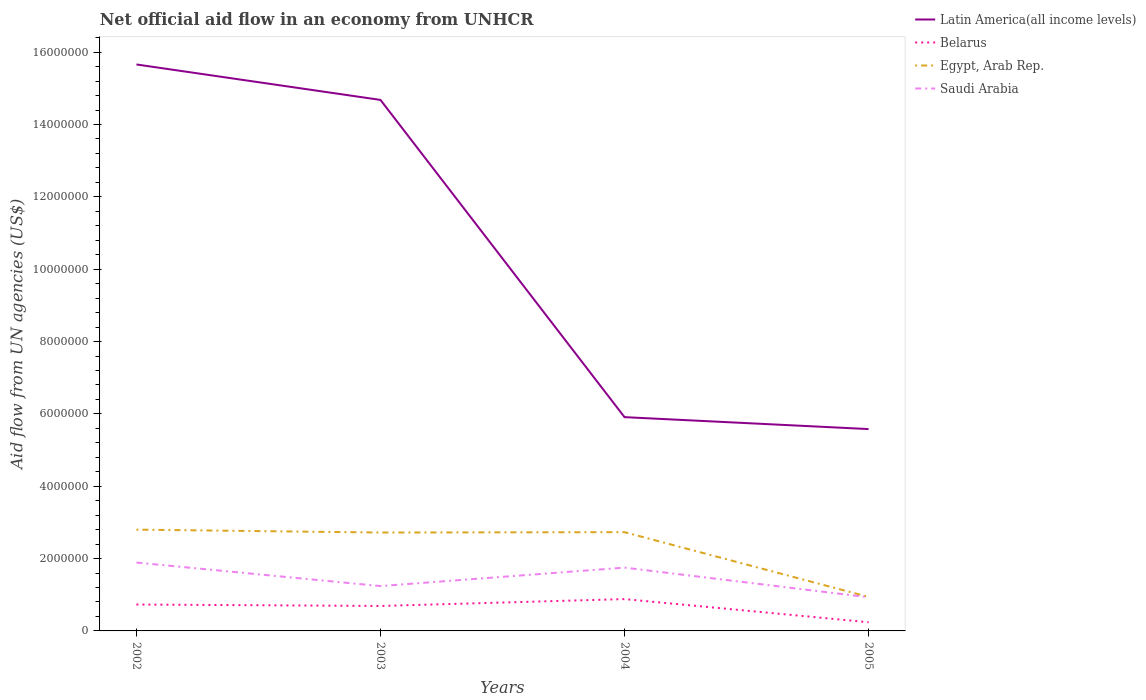How many different coloured lines are there?
Offer a very short reply. 4. Is the number of lines equal to the number of legend labels?
Your answer should be very brief. Yes. Across all years, what is the maximum net official aid flow in Egypt, Arab Rep.?
Make the answer very short. 9.40e+05. What is the total net official aid flow in Latin America(all income levels) in the graph?
Make the answer very short. 1.01e+07. What is the difference between the highest and the second highest net official aid flow in Latin America(all income levels)?
Your answer should be compact. 1.01e+07. Does the graph contain any zero values?
Your answer should be very brief. No. Does the graph contain grids?
Your answer should be compact. No. Where does the legend appear in the graph?
Keep it short and to the point. Top right. How are the legend labels stacked?
Make the answer very short. Vertical. What is the title of the graph?
Give a very brief answer. Net official aid flow in an economy from UNHCR. What is the label or title of the X-axis?
Keep it short and to the point. Years. What is the label or title of the Y-axis?
Your answer should be very brief. Aid flow from UN agencies (US$). What is the Aid flow from UN agencies (US$) in Latin America(all income levels) in 2002?
Offer a very short reply. 1.57e+07. What is the Aid flow from UN agencies (US$) of Belarus in 2002?
Make the answer very short. 7.30e+05. What is the Aid flow from UN agencies (US$) in Egypt, Arab Rep. in 2002?
Your answer should be very brief. 2.80e+06. What is the Aid flow from UN agencies (US$) in Saudi Arabia in 2002?
Your answer should be compact. 1.89e+06. What is the Aid flow from UN agencies (US$) in Latin America(all income levels) in 2003?
Provide a succinct answer. 1.47e+07. What is the Aid flow from UN agencies (US$) of Belarus in 2003?
Give a very brief answer. 6.90e+05. What is the Aid flow from UN agencies (US$) in Egypt, Arab Rep. in 2003?
Give a very brief answer. 2.72e+06. What is the Aid flow from UN agencies (US$) in Saudi Arabia in 2003?
Keep it short and to the point. 1.24e+06. What is the Aid flow from UN agencies (US$) in Latin America(all income levels) in 2004?
Provide a short and direct response. 5.91e+06. What is the Aid flow from UN agencies (US$) of Belarus in 2004?
Ensure brevity in your answer.  8.80e+05. What is the Aid flow from UN agencies (US$) in Egypt, Arab Rep. in 2004?
Provide a succinct answer. 2.73e+06. What is the Aid flow from UN agencies (US$) of Saudi Arabia in 2004?
Give a very brief answer. 1.75e+06. What is the Aid flow from UN agencies (US$) in Latin America(all income levels) in 2005?
Offer a terse response. 5.58e+06. What is the Aid flow from UN agencies (US$) in Egypt, Arab Rep. in 2005?
Ensure brevity in your answer.  9.40e+05. What is the Aid flow from UN agencies (US$) in Saudi Arabia in 2005?
Offer a very short reply. 9.30e+05. Across all years, what is the maximum Aid flow from UN agencies (US$) in Latin America(all income levels)?
Keep it short and to the point. 1.57e+07. Across all years, what is the maximum Aid flow from UN agencies (US$) in Belarus?
Give a very brief answer. 8.80e+05. Across all years, what is the maximum Aid flow from UN agencies (US$) of Egypt, Arab Rep.?
Make the answer very short. 2.80e+06. Across all years, what is the maximum Aid flow from UN agencies (US$) in Saudi Arabia?
Provide a succinct answer. 1.89e+06. Across all years, what is the minimum Aid flow from UN agencies (US$) of Latin America(all income levels)?
Ensure brevity in your answer.  5.58e+06. Across all years, what is the minimum Aid flow from UN agencies (US$) in Belarus?
Provide a short and direct response. 2.40e+05. Across all years, what is the minimum Aid flow from UN agencies (US$) in Egypt, Arab Rep.?
Your answer should be compact. 9.40e+05. Across all years, what is the minimum Aid flow from UN agencies (US$) in Saudi Arabia?
Ensure brevity in your answer.  9.30e+05. What is the total Aid flow from UN agencies (US$) of Latin America(all income levels) in the graph?
Keep it short and to the point. 4.18e+07. What is the total Aid flow from UN agencies (US$) in Belarus in the graph?
Your answer should be compact. 2.54e+06. What is the total Aid flow from UN agencies (US$) in Egypt, Arab Rep. in the graph?
Ensure brevity in your answer.  9.19e+06. What is the total Aid flow from UN agencies (US$) of Saudi Arabia in the graph?
Ensure brevity in your answer.  5.81e+06. What is the difference between the Aid flow from UN agencies (US$) in Latin America(all income levels) in 2002 and that in 2003?
Provide a short and direct response. 9.80e+05. What is the difference between the Aid flow from UN agencies (US$) of Belarus in 2002 and that in 2003?
Ensure brevity in your answer.  4.00e+04. What is the difference between the Aid flow from UN agencies (US$) in Egypt, Arab Rep. in 2002 and that in 2003?
Your response must be concise. 8.00e+04. What is the difference between the Aid flow from UN agencies (US$) in Saudi Arabia in 2002 and that in 2003?
Your answer should be very brief. 6.50e+05. What is the difference between the Aid flow from UN agencies (US$) of Latin America(all income levels) in 2002 and that in 2004?
Offer a very short reply. 9.75e+06. What is the difference between the Aid flow from UN agencies (US$) in Belarus in 2002 and that in 2004?
Provide a short and direct response. -1.50e+05. What is the difference between the Aid flow from UN agencies (US$) in Saudi Arabia in 2002 and that in 2004?
Ensure brevity in your answer.  1.40e+05. What is the difference between the Aid flow from UN agencies (US$) of Latin America(all income levels) in 2002 and that in 2005?
Offer a terse response. 1.01e+07. What is the difference between the Aid flow from UN agencies (US$) of Egypt, Arab Rep. in 2002 and that in 2005?
Make the answer very short. 1.86e+06. What is the difference between the Aid flow from UN agencies (US$) of Saudi Arabia in 2002 and that in 2005?
Your answer should be compact. 9.60e+05. What is the difference between the Aid flow from UN agencies (US$) in Latin America(all income levels) in 2003 and that in 2004?
Provide a short and direct response. 8.77e+06. What is the difference between the Aid flow from UN agencies (US$) of Belarus in 2003 and that in 2004?
Keep it short and to the point. -1.90e+05. What is the difference between the Aid flow from UN agencies (US$) in Egypt, Arab Rep. in 2003 and that in 2004?
Your answer should be compact. -10000. What is the difference between the Aid flow from UN agencies (US$) in Saudi Arabia in 2003 and that in 2004?
Ensure brevity in your answer.  -5.10e+05. What is the difference between the Aid flow from UN agencies (US$) in Latin America(all income levels) in 2003 and that in 2005?
Keep it short and to the point. 9.10e+06. What is the difference between the Aid flow from UN agencies (US$) in Belarus in 2003 and that in 2005?
Your answer should be very brief. 4.50e+05. What is the difference between the Aid flow from UN agencies (US$) in Egypt, Arab Rep. in 2003 and that in 2005?
Keep it short and to the point. 1.78e+06. What is the difference between the Aid flow from UN agencies (US$) of Belarus in 2004 and that in 2005?
Make the answer very short. 6.40e+05. What is the difference between the Aid flow from UN agencies (US$) in Egypt, Arab Rep. in 2004 and that in 2005?
Offer a very short reply. 1.79e+06. What is the difference between the Aid flow from UN agencies (US$) of Saudi Arabia in 2004 and that in 2005?
Offer a terse response. 8.20e+05. What is the difference between the Aid flow from UN agencies (US$) of Latin America(all income levels) in 2002 and the Aid flow from UN agencies (US$) of Belarus in 2003?
Keep it short and to the point. 1.50e+07. What is the difference between the Aid flow from UN agencies (US$) in Latin America(all income levels) in 2002 and the Aid flow from UN agencies (US$) in Egypt, Arab Rep. in 2003?
Keep it short and to the point. 1.29e+07. What is the difference between the Aid flow from UN agencies (US$) of Latin America(all income levels) in 2002 and the Aid flow from UN agencies (US$) of Saudi Arabia in 2003?
Provide a succinct answer. 1.44e+07. What is the difference between the Aid flow from UN agencies (US$) of Belarus in 2002 and the Aid flow from UN agencies (US$) of Egypt, Arab Rep. in 2003?
Offer a terse response. -1.99e+06. What is the difference between the Aid flow from UN agencies (US$) of Belarus in 2002 and the Aid flow from UN agencies (US$) of Saudi Arabia in 2003?
Provide a succinct answer. -5.10e+05. What is the difference between the Aid flow from UN agencies (US$) of Egypt, Arab Rep. in 2002 and the Aid flow from UN agencies (US$) of Saudi Arabia in 2003?
Your answer should be compact. 1.56e+06. What is the difference between the Aid flow from UN agencies (US$) in Latin America(all income levels) in 2002 and the Aid flow from UN agencies (US$) in Belarus in 2004?
Offer a terse response. 1.48e+07. What is the difference between the Aid flow from UN agencies (US$) in Latin America(all income levels) in 2002 and the Aid flow from UN agencies (US$) in Egypt, Arab Rep. in 2004?
Give a very brief answer. 1.29e+07. What is the difference between the Aid flow from UN agencies (US$) of Latin America(all income levels) in 2002 and the Aid flow from UN agencies (US$) of Saudi Arabia in 2004?
Your answer should be compact. 1.39e+07. What is the difference between the Aid flow from UN agencies (US$) of Belarus in 2002 and the Aid flow from UN agencies (US$) of Egypt, Arab Rep. in 2004?
Offer a very short reply. -2.00e+06. What is the difference between the Aid flow from UN agencies (US$) in Belarus in 2002 and the Aid flow from UN agencies (US$) in Saudi Arabia in 2004?
Your response must be concise. -1.02e+06. What is the difference between the Aid flow from UN agencies (US$) of Egypt, Arab Rep. in 2002 and the Aid flow from UN agencies (US$) of Saudi Arabia in 2004?
Your response must be concise. 1.05e+06. What is the difference between the Aid flow from UN agencies (US$) of Latin America(all income levels) in 2002 and the Aid flow from UN agencies (US$) of Belarus in 2005?
Ensure brevity in your answer.  1.54e+07. What is the difference between the Aid flow from UN agencies (US$) in Latin America(all income levels) in 2002 and the Aid flow from UN agencies (US$) in Egypt, Arab Rep. in 2005?
Offer a terse response. 1.47e+07. What is the difference between the Aid flow from UN agencies (US$) of Latin America(all income levels) in 2002 and the Aid flow from UN agencies (US$) of Saudi Arabia in 2005?
Provide a succinct answer. 1.47e+07. What is the difference between the Aid flow from UN agencies (US$) of Belarus in 2002 and the Aid flow from UN agencies (US$) of Saudi Arabia in 2005?
Provide a succinct answer. -2.00e+05. What is the difference between the Aid flow from UN agencies (US$) in Egypt, Arab Rep. in 2002 and the Aid flow from UN agencies (US$) in Saudi Arabia in 2005?
Your response must be concise. 1.87e+06. What is the difference between the Aid flow from UN agencies (US$) of Latin America(all income levels) in 2003 and the Aid flow from UN agencies (US$) of Belarus in 2004?
Your answer should be compact. 1.38e+07. What is the difference between the Aid flow from UN agencies (US$) of Latin America(all income levels) in 2003 and the Aid flow from UN agencies (US$) of Egypt, Arab Rep. in 2004?
Provide a succinct answer. 1.20e+07. What is the difference between the Aid flow from UN agencies (US$) of Latin America(all income levels) in 2003 and the Aid flow from UN agencies (US$) of Saudi Arabia in 2004?
Your answer should be compact. 1.29e+07. What is the difference between the Aid flow from UN agencies (US$) of Belarus in 2003 and the Aid flow from UN agencies (US$) of Egypt, Arab Rep. in 2004?
Offer a terse response. -2.04e+06. What is the difference between the Aid flow from UN agencies (US$) of Belarus in 2003 and the Aid flow from UN agencies (US$) of Saudi Arabia in 2004?
Your answer should be very brief. -1.06e+06. What is the difference between the Aid flow from UN agencies (US$) in Egypt, Arab Rep. in 2003 and the Aid flow from UN agencies (US$) in Saudi Arabia in 2004?
Your answer should be compact. 9.70e+05. What is the difference between the Aid flow from UN agencies (US$) in Latin America(all income levels) in 2003 and the Aid flow from UN agencies (US$) in Belarus in 2005?
Provide a short and direct response. 1.44e+07. What is the difference between the Aid flow from UN agencies (US$) of Latin America(all income levels) in 2003 and the Aid flow from UN agencies (US$) of Egypt, Arab Rep. in 2005?
Make the answer very short. 1.37e+07. What is the difference between the Aid flow from UN agencies (US$) in Latin America(all income levels) in 2003 and the Aid flow from UN agencies (US$) in Saudi Arabia in 2005?
Give a very brief answer. 1.38e+07. What is the difference between the Aid flow from UN agencies (US$) of Belarus in 2003 and the Aid flow from UN agencies (US$) of Egypt, Arab Rep. in 2005?
Provide a short and direct response. -2.50e+05. What is the difference between the Aid flow from UN agencies (US$) of Egypt, Arab Rep. in 2003 and the Aid flow from UN agencies (US$) of Saudi Arabia in 2005?
Your response must be concise. 1.79e+06. What is the difference between the Aid flow from UN agencies (US$) of Latin America(all income levels) in 2004 and the Aid flow from UN agencies (US$) of Belarus in 2005?
Keep it short and to the point. 5.67e+06. What is the difference between the Aid flow from UN agencies (US$) of Latin America(all income levels) in 2004 and the Aid flow from UN agencies (US$) of Egypt, Arab Rep. in 2005?
Offer a terse response. 4.97e+06. What is the difference between the Aid flow from UN agencies (US$) of Latin America(all income levels) in 2004 and the Aid flow from UN agencies (US$) of Saudi Arabia in 2005?
Keep it short and to the point. 4.98e+06. What is the difference between the Aid flow from UN agencies (US$) of Belarus in 2004 and the Aid flow from UN agencies (US$) of Saudi Arabia in 2005?
Provide a succinct answer. -5.00e+04. What is the difference between the Aid flow from UN agencies (US$) in Egypt, Arab Rep. in 2004 and the Aid flow from UN agencies (US$) in Saudi Arabia in 2005?
Give a very brief answer. 1.80e+06. What is the average Aid flow from UN agencies (US$) of Latin America(all income levels) per year?
Make the answer very short. 1.05e+07. What is the average Aid flow from UN agencies (US$) in Belarus per year?
Keep it short and to the point. 6.35e+05. What is the average Aid flow from UN agencies (US$) in Egypt, Arab Rep. per year?
Ensure brevity in your answer.  2.30e+06. What is the average Aid flow from UN agencies (US$) of Saudi Arabia per year?
Your answer should be compact. 1.45e+06. In the year 2002, what is the difference between the Aid flow from UN agencies (US$) in Latin America(all income levels) and Aid flow from UN agencies (US$) in Belarus?
Keep it short and to the point. 1.49e+07. In the year 2002, what is the difference between the Aid flow from UN agencies (US$) in Latin America(all income levels) and Aid flow from UN agencies (US$) in Egypt, Arab Rep.?
Your response must be concise. 1.29e+07. In the year 2002, what is the difference between the Aid flow from UN agencies (US$) of Latin America(all income levels) and Aid flow from UN agencies (US$) of Saudi Arabia?
Provide a short and direct response. 1.38e+07. In the year 2002, what is the difference between the Aid flow from UN agencies (US$) in Belarus and Aid flow from UN agencies (US$) in Egypt, Arab Rep.?
Provide a succinct answer. -2.07e+06. In the year 2002, what is the difference between the Aid flow from UN agencies (US$) in Belarus and Aid flow from UN agencies (US$) in Saudi Arabia?
Offer a very short reply. -1.16e+06. In the year 2002, what is the difference between the Aid flow from UN agencies (US$) in Egypt, Arab Rep. and Aid flow from UN agencies (US$) in Saudi Arabia?
Ensure brevity in your answer.  9.10e+05. In the year 2003, what is the difference between the Aid flow from UN agencies (US$) of Latin America(all income levels) and Aid flow from UN agencies (US$) of Belarus?
Your response must be concise. 1.40e+07. In the year 2003, what is the difference between the Aid flow from UN agencies (US$) of Latin America(all income levels) and Aid flow from UN agencies (US$) of Egypt, Arab Rep.?
Provide a short and direct response. 1.20e+07. In the year 2003, what is the difference between the Aid flow from UN agencies (US$) of Latin America(all income levels) and Aid flow from UN agencies (US$) of Saudi Arabia?
Ensure brevity in your answer.  1.34e+07. In the year 2003, what is the difference between the Aid flow from UN agencies (US$) of Belarus and Aid flow from UN agencies (US$) of Egypt, Arab Rep.?
Offer a very short reply. -2.03e+06. In the year 2003, what is the difference between the Aid flow from UN agencies (US$) in Belarus and Aid flow from UN agencies (US$) in Saudi Arabia?
Offer a terse response. -5.50e+05. In the year 2003, what is the difference between the Aid flow from UN agencies (US$) in Egypt, Arab Rep. and Aid flow from UN agencies (US$) in Saudi Arabia?
Your answer should be compact. 1.48e+06. In the year 2004, what is the difference between the Aid flow from UN agencies (US$) in Latin America(all income levels) and Aid flow from UN agencies (US$) in Belarus?
Offer a terse response. 5.03e+06. In the year 2004, what is the difference between the Aid flow from UN agencies (US$) in Latin America(all income levels) and Aid flow from UN agencies (US$) in Egypt, Arab Rep.?
Offer a very short reply. 3.18e+06. In the year 2004, what is the difference between the Aid flow from UN agencies (US$) in Latin America(all income levels) and Aid flow from UN agencies (US$) in Saudi Arabia?
Your response must be concise. 4.16e+06. In the year 2004, what is the difference between the Aid flow from UN agencies (US$) of Belarus and Aid flow from UN agencies (US$) of Egypt, Arab Rep.?
Offer a terse response. -1.85e+06. In the year 2004, what is the difference between the Aid flow from UN agencies (US$) in Belarus and Aid flow from UN agencies (US$) in Saudi Arabia?
Make the answer very short. -8.70e+05. In the year 2004, what is the difference between the Aid flow from UN agencies (US$) of Egypt, Arab Rep. and Aid flow from UN agencies (US$) of Saudi Arabia?
Offer a very short reply. 9.80e+05. In the year 2005, what is the difference between the Aid flow from UN agencies (US$) of Latin America(all income levels) and Aid flow from UN agencies (US$) of Belarus?
Your answer should be compact. 5.34e+06. In the year 2005, what is the difference between the Aid flow from UN agencies (US$) in Latin America(all income levels) and Aid flow from UN agencies (US$) in Egypt, Arab Rep.?
Your response must be concise. 4.64e+06. In the year 2005, what is the difference between the Aid flow from UN agencies (US$) in Latin America(all income levels) and Aid flow from UN agencies (US$) in Saudi Arabia?
Keep it short and to the point. 4.65e+06. In the year 2005, what is the difference between the Aid flow from UN agencies (US$) of Belarus and Aid flow from UN agencies (US$) of Egypt, Arab Rep.?
Make the answer very short. -7.00e+05. In the year 2005, what is the difference between the Aid flow from UN agencies (US$) in Belarus and Aid flow from UN agencies (US$) in Saudi Arabia?
Your answer should be very brief. -6.90e+05. What is the ratio of the Aid flow from UN agencies (US$) of Latin America(all income levels) in 2002 to that in 2003?
Your answer should be very brief. 1.07. What is the ratio of the Aid flow from UN agencies (US$) in Belarus in 2002 to that in 2003?
Offer a terse response. 1.06. What is the ratio of the Aid flow from UN agencies (US$) of Egypt, Arab Rep. in 2002 to that in 2003?
Offer a very short reply. 1.03. What is the ratio of the Aid flow from UN agencies (US$) of Saudi Arabia in 2002 to that in 2003?
Provide a succinct answer. 1.52. What is the ratio of the Aid flow from UN agencies (US$) of Latin America(all income levels) in 2002 to that in 2004?
Give a very brief answer. 2.65. What is the ratio of the Aid flow from UN agencies (US$) of Belarus in 2002 to that in 2004?
Your answer should be compact. 0.83. What is the ratio of the Aid flow from UN agencies (US$) in Egypt, Arab Rep. in 2002 to that in 2004?
Offer a terse response. 1.03. What is the ratio of the Aid flow from UN agencies (US$) in Saudi Arabia in 2002 to that in 2004?
Offer a terse response. 1.08. What is the ratio of the Aid flow from UN agencies (US$) in Latin America(all income levels) in 2002 to that in 2005?
Your answer should be very brief. 2.81. What is the ratio of the Aid flow from UN agencies (US$) in Belarus in 2002 to that in 2005?
Keep it short and to the point. 3.04. What is the ratio of the Aid flow from UN agencies (US$) in Egypt, Arab Rep. in 2002 to that in 2005?
Make the answer very short. 2.98. What is the ratio of the Aid flow from UN agencies (US$) in Saudi Arabia in 2002 to that in 2005?
Your answer should be compact. 2.03. What is the ratio of the Aid flow from UN agencies (US$) of Latin America(all income levels) in 2003 to that in 2004?
Your answer should be very brief. 2.48. What is the ratio of the Aid flow from UN agencies (US$) in Belarus in 2003 to that in 2004?
Keep it short and to the point. 0.78. What is the ratio of the Aid flow from UN agencies (US$) in Saudi Arabia in 2003 to that in 2004?
Your response must be concise. 0.71. What is the ratio of the Aid flow from UN agencies (US$) of Latin America(all income levels) in 2003 to that in 2005?
Keep it short and to the point. 2.63. What is the ratio of the Aid flow from UN agencies (US$) in Belarus in 2003 to that in 2005?
Your response must be concise. 2.88. What is the ratio of the Aid flow from UN agencies (US$) in Egypt, Arab Rep. in 2003 to that in 2005?
Your response must be concise. 2.89. What is the ratio of the Aid flow from UN agencies (US$) of Latin America(all income levels) in 2004 to that in 2005?
Offer a very short reply. 1.06. What is the ratio of the Aid flow from UN agencies (US$) of Belarus in 2004 to that in 2005?
Provide a short and direct response. 3.67. What is the ratio of the Aid flow from UN agencies (US$) of Egypt, Arab Rep. in 2004 to that in 2005?
Keep it short and to the point. 2.9. What is the ratio of the Aid flow from UN agencies (US$) in Saudi Arabia in 2004 to that in 2005?
Your answer should be very brief. 1.88. What is the difference between the highest and the second highest Aid flow from UN agencies (US$) in Latin America(all income levels)?
Your response must be concise. 9.80e+05. What is the difference between the highest and the second highest Aid flow from UN agencies (US$) in Saudi Arabia?
Ensure brevity in your answer.  1.40e+05. What is the difference between the highest and the lowest Aid flow from UN agencies (US$) in Latin America(all income levels)?
Offer a very short reply. 1.01e+07. What is the difference between the highest and the lowest Aid flow from UN agencies (US$) in Belarus?
Offer a terse response. 6.40e+05. What is the difference between the highest and the lowest Aid flow from UN agencies (US$) of Egypt, Arab Rep.?
Your answer should be very brief. 1.86e+06. What is the difference between the highest and the lowest Aid flow from UN agencies (US$) in Saudi Arabia?
Ensure brevity in your answer.  9.60e+05. 